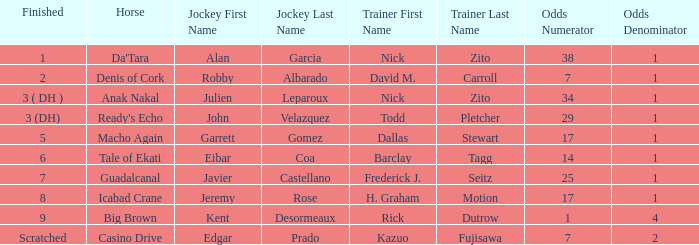Who is the Jockey for guadalcanal? Javier Castellano. 